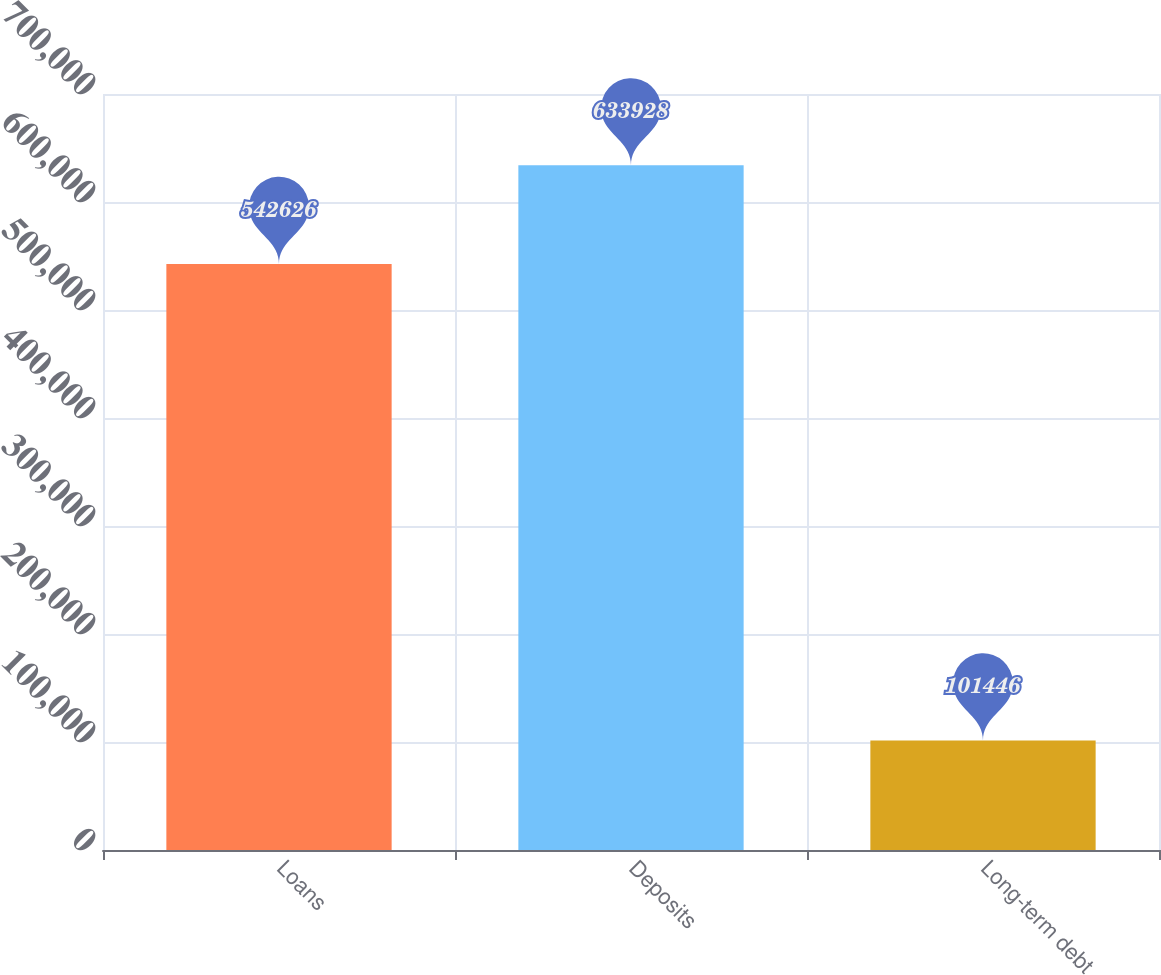Convert chart. <chart><loc_0><loc_0><loc_500><loc_500><bar_chart><fcel>Loans<fcel>Deposits<fcel>Long-term debt<nl><fcel>542626<fcel>633928<fcel>101446<nl></chart> 